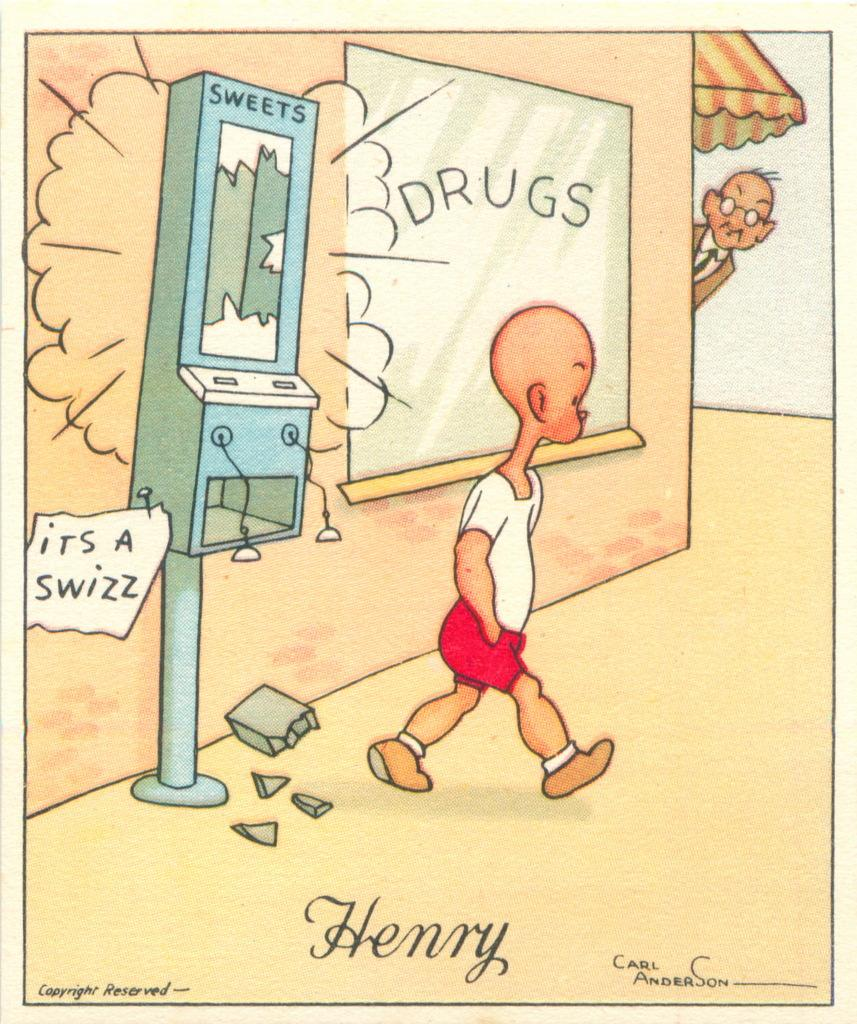What type of image is depicted in the picture? The image contains a drawing of a cartoon picture. Can you describe the scene in the drawing? There is a kid walking in the drawing. Are there any other characters or actions in the drawing? Yes, there is a man looking at someone in the right corner of the drawing. What type of business is the man conducting in the drawing? There is no indication of a business in the drawing; it features a cartoon scene with a kid walking and a man looking at someone. What degree does the kid have in the drawing? There is no mention of degrees or education in the drawing; it is a simple cartoon scene. 